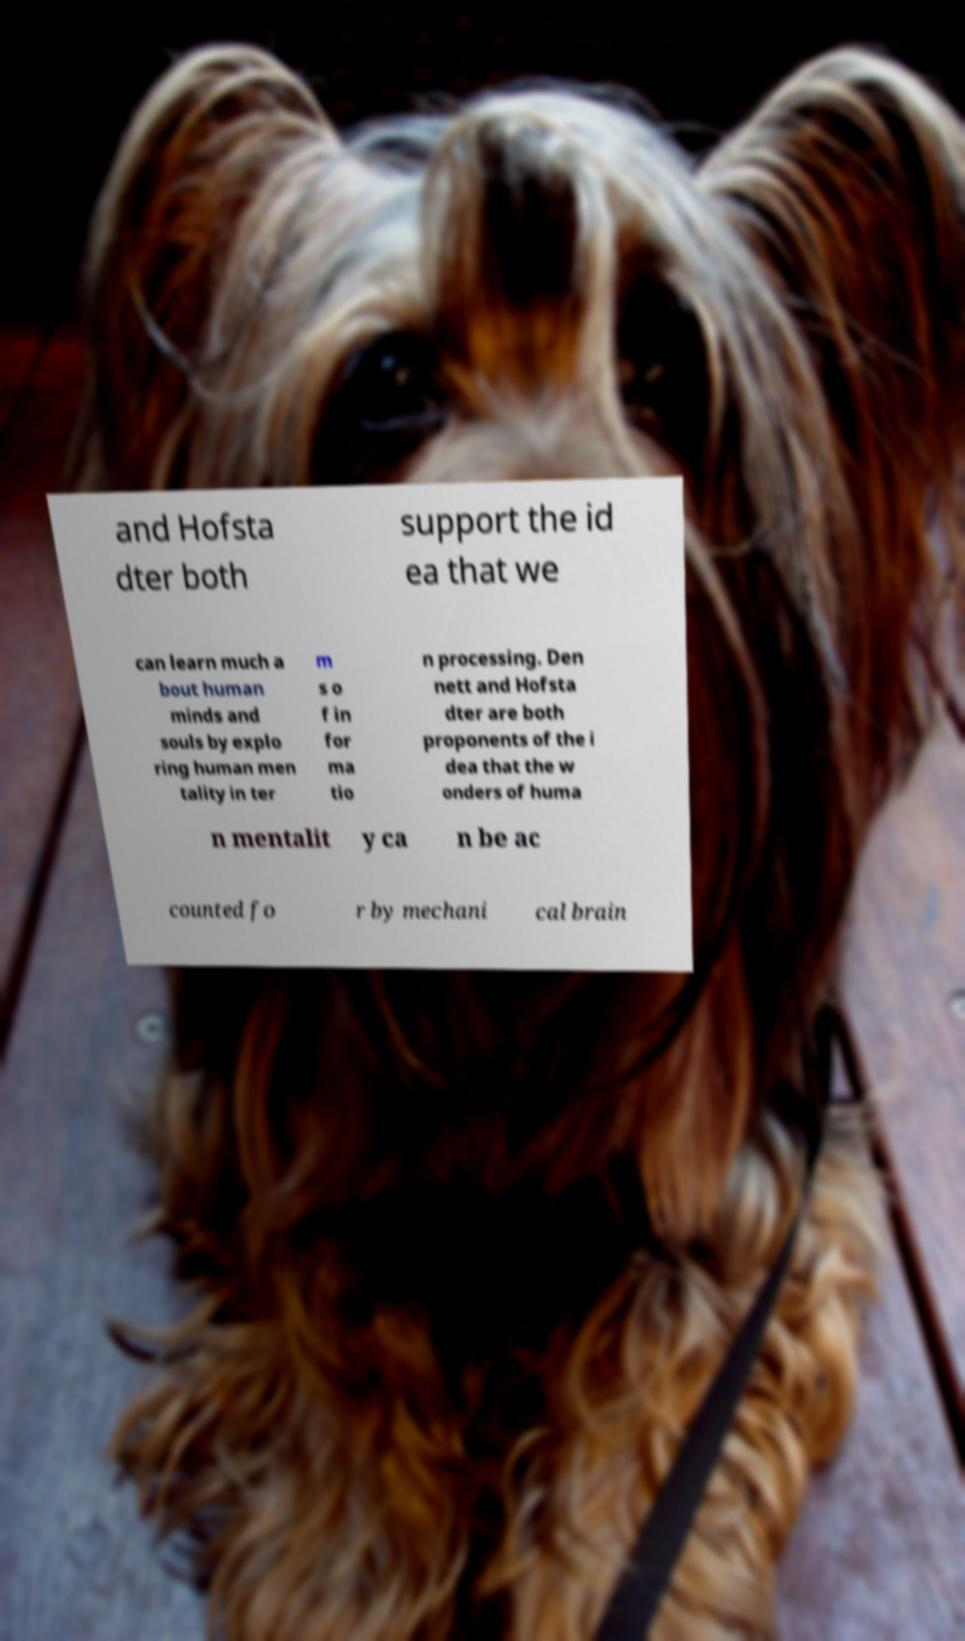Can you accurately transcribe the text from the provided image for me? and Hofsta dter both support the id ea that we can learn much a bout human minds and souls by explo ring human men tality in ter m s o f in for ma tio n processing. Den nett and Hofsta dter are both proponents of the i dea that the w onders of huma n mentalit y ca n be ac counted fo r by mechani cal brain 